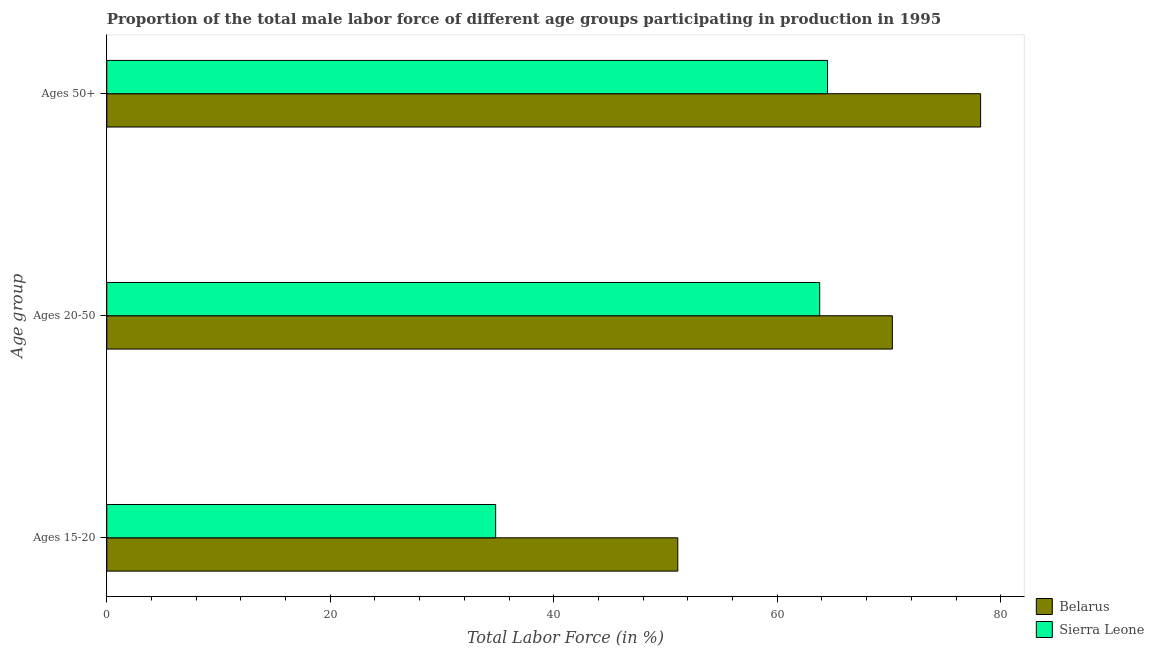How many different coloured bars are there?
Give a very brief answer. 2. How many groups of bars are there?
Your answer should be compact. 3. How many bars are there on the 3rd tick from the top?
Provide a short and direct response. 2. How many bars are there on the 1st tick from the bottom?
Provide a short and direct response. 2. What is the label of the 1st group of bars from the top?
Make the answer very short. Ages 50+. What is the percentage of male labor force within the age group 15-20 in Belarus?
Provide a short and direct response. 51.1. Across all countries, what is the maximum percentage of male labor force within the age group 20-50?
Keep it short and to the point. 70.3. Across all countries, what is the minimum percentage of male labor force above age 50?
Ensure brevity in your answer.  64.5. In which country was the percentage of male labor force within the age group 20-50 maximum?
Keep it short and to the point. Belarus. In which country was the percentage of male labor force within the age group 20-50 minimum?
Your answer should be compact. Sierra Leone. What is the total percentage of male labor force within the age group 15-20 in the graph?
Offer a terse response. 85.9. What is the difference between the percentage of male labor force within the age group 20-50 in Belarus and that in Sierra Leone?
Your answer should be very brief. 6.5. What is the difference between the percentage of male labor force within the age group 15-20 in Belarus and the percentage of male labor force within the age group 20-50 in Sierra Leone?
Give a very brief answer. -12.7. What is the average percentage of male labor force above age 50 per country?
Provide a succinct answer. 71.35. What is the difference between the percentage of male labor force above age 50 and percentage of male labor force within the age group 20-50 in Sierra Leone?
Your response must be concise. 0.7. What is the ratio of the percentage of male labor force above age 50 in Belarus to that in Sierra Leone?
Your answer should be compact. 1.21. Is the percentage of male labor force within the age group 15-20 in Belarus less than that in Sierra Leone?
Ensure brevity in your answer.  No. Is the difference between the percentage of male labor force above age 50 in Sierra Leone and Belarus greater than the difference between the percentage of male labor force within the age group 15-20 in Sierra Leone and Belarus?
Provide a succinct answer. Yes. What is the difference between the highest and the second highest percentage of male labor force within the age group 15-20?
Your answer should be very brief. 16.3. What is the difference between the highest and the lowest percentage of male labor force above age 50?
Provide a succinct answer. 13.7. In how many countries, is the percentage of male labor force above age 50 greater than the average percentage of male labor force above age 50 taken over all countries?
Keep it short and to the point. 1. Is the sum of the percentage of male labor force within the age group 20-50 in Belarus and Sierra Leone greater than the maximum percentage of male labor force within the age group 15-20 across all countries?
Your response must be concise. Yes. What does the 1st bar from the top in Ages 50+ represents?
Your answer should be compact. Sierra Leone. What does the 2nd bar from the bottom in Ages 15-20 represents?
Your answer should be very brief. Sierra Leone. Is it the case that in every country, the sum of the percentage of male labor force within the age group 15-20 and percentage of male labor force within the age group 20-50 is greater than the percentage of male labor force above age 50?
Provide a short and direct response. Yes. Are all the bars in the graph horizontal?
Ensure brevity in your answer.  Yes. Does the graph contain grids?
Ensure brevity in your answer.  No. How are the legend labels stacked?
Give a very brief answer. Vertical. What is the title of the graph?
Provide a short and direct response. Proportion of the total male labor force of different age groups participating in production in 1995. Does "Brunei Darussalam" appear as one of the legend labels in the graph?
Your answer should be very brief. No. What is the label or title of the X-axis?
Make the answer very short. Total Labor Force (in %). What is the label or title of the Y-axis?
Provide a succinct answer. Age group. What is the Total Labor Force (in %) of Belarus in Ages 15-20?
Your answer should be very brief. 51.1. What is the Total Labor Force (in %) in Sierra Leone in Ages 15-20?
Provide a short and direct response. 34.8. What is the Total Labor Force (in %) in Belarus in Ages 20-50?
Provide a succinct answer. 70.3. What is the Total Labor Force (in %) in Sierra Leone in Ages 20-50?
Your answer should be very brief. 63.8. What is the Total Labor Force (in %) of Belarus in Ages 50+?
Give a very brief answer. 78.2. What is the Total Labor Force (in %) of Sierra Leone in Ages 50+?
Your answer should be very brief. 64.5. Across all Age group, what is the maximum Total Labor Force (in %) in Belarus?
Give a very brief answer. 78.2. Across all Age group, what is the maximum Total Labor Force (in %) in Sierra Leone?
Offer a very short reply. 64.5. Across all Age group, what is the minimum Total Labor Force (in %) in Belarus?
Offer a terse response. 51.1. Across all Age group, what is the minimum Total Labor Force (in %) of Sierra Leone?
Make the answer very short. 34.8. What is the total Total Labor Force (in %) in Belarus in the graph?
Your answer should be very brief. 199.6. What is the total Total Labor Force (in %) in Sierra Leone in the graph?
Your response must be concise. 163.1. What is the difference between the Total Labor Force (in %) in Belarus in Ages 15-20 and that in Ages 20-50?
Provide a short and direct response. -19.2. What is the difference between the Total Labor Force (in %) of Belarus in Ages 15-20 and that in Ages 50+?
Your answer should be compact. -27.1. What is the difference between the Total Labor Force (in %) of Sierra Leone in Ages 15-20 and that in Ages 50+?
Provide a short and direct response. -29.7. What is the difference between the Total Labor Force (in %) in Sierra Leone in Ages 20-50 and that in Ages 50+?
Your response must be concise. -0.7. What is the difference between the Total Labor Force (in %) of Belarus in Ages 15-20 and the Total Labor Force (in %) of Sierra Leone in Ages 50+?
Ensure brevity in your answer.  -13.4. What is the difference between the Total Labor Force (in %) in Belarus in Ages 20-50 and the Total Labor Force (in %) in Sierra Leone in Ages 50+?
Provide a short and direct response. 5.8. What is the average Total Labor Force (in %) in Belarus per Age group?
Offer a terse response. 66.53. What is the average Total Labor Force (in %) of Sierra Leone per Age group?
Your response must be concise. 54.37. What is the difference between the Total Labor Force (in %) of Belarus and Total Labor Force (in %) of Sierra Leone in Ages 15-20?
Keep it short and to the point. 16.3. What is the difference between the Total Labor Force (in %) in Belarus and Total Labor Force (in %) in Sierra Leone in Ages 50+?
Offer a terse response. 13.7. What is the ratio of the Total Labor Force (in %) of Belarus in Ages 15-20 to that in Ages 20-50?
Your answer should be compact. 0.73. What is the ratio of the Total Labor Force (in %) of Sierra Leone in Ages 15-20 to that in Ages 20-50?
Your answer should be very brief. 0.55. What is the ratio of the Total Labor Force (in %) of Belarus in Ages 15-20 to that in Ages 50+?
Provide a succinct answer. 0.65. What is the ratio of the Total Labor Force (in %) in Sierra Leone in Ages 15-20 to that in Ages 50+?
Ensure brevity in your answer.  0.54. What is the ratio of the Total Labor Force (in %) of Belarus in Ages 20-50 to that in Ages 50+?
Your answer should be very brief. 0.9. What is the ratio of the Total Labor Force (in %) of Sierra Leone in Ages 20-50 to that in Ages 50+?
Offer a terse response. 0.99. What is the difference between the highest and the second highest Total Labor Force (in %) in Sierra Leone?
Provide a succinct answer. 0.7. What is the difference between the highest and the lowest Total Labor Force (in %) in Belarus?
Your response must be concise. 27.1. What is the difference between the highest and the lowest Total Labor Force (in %) of Sierra Leone?
Keep it short and to the point. 29.7. 